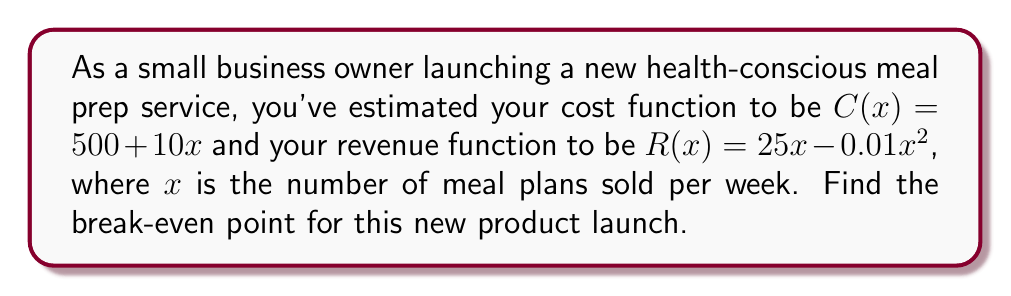Teach me how to tackle this problem. To find the break-even point, we need to determine where the cost function equals the revenue function. Let's approach this step-by-step:

1) At the break-even point, Cost = Revenue
   $C(x) = R(x)$

2) Substitute the given functions:
   $500 + 10x = 25x - 0.01x^2$

3) Rearrange the equation:
   $0.01x^2 - 15x + 500 = 0$

4) This is a quadratic equation. We can solve it using the quadratic formula:
   $x = \frac{-b \pm \sqrt{b^2 - 4ac}}{2a}$

   Where $a = 0.01$, $b = -15$, and $c = 500$

5) Substitute these values:
   $x = \frac{15 \pm \sqrt{(-15)^2 - 4(0.01)(500)}}{2(0.01)}$

6) Simplify:
   $x = \frac{15 \pm \sqrt{225 - 20}}{0.02} = \frac{15 \pm \sqrt{205}}{0.02}$

7) Calculate:
   $x \approx 33.7$ or $x \approx 1466.3$

8) Since we can't sell a fractional number of meal plans, and the larger solution is unrealistic for a small business, we round up the smaller solution.

Therefore, the break-even point is 34 meal plans per week.
Answer: 34 meal plans per week 